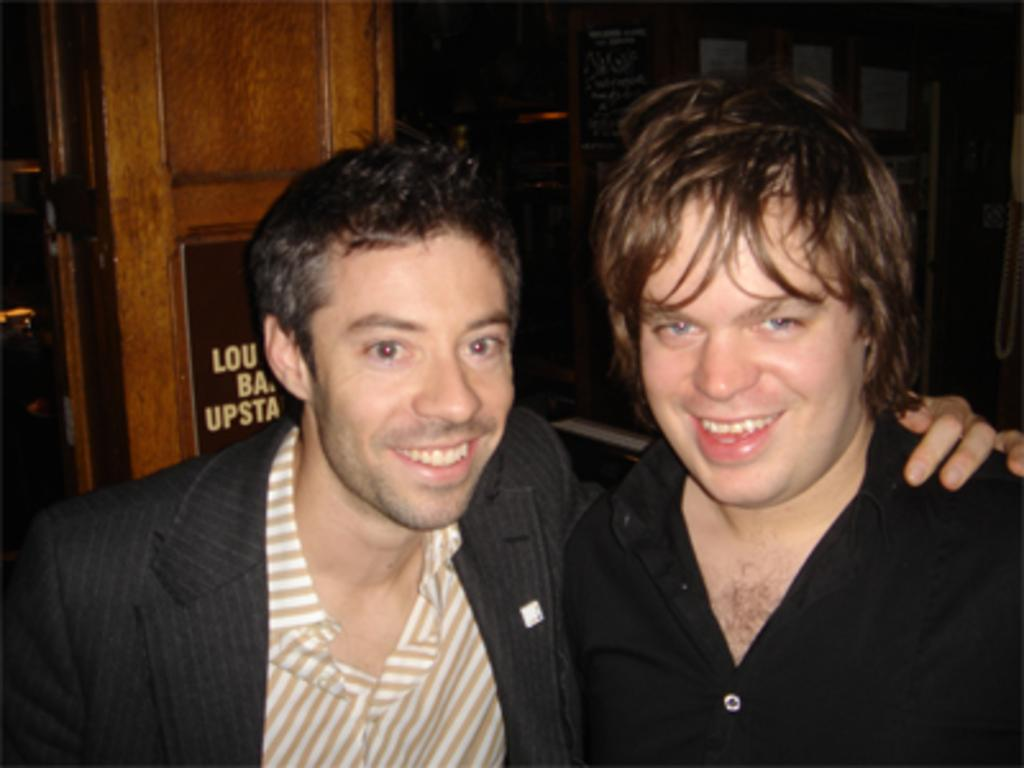How many people are in the image? There are two persons in the image. What are the people wearing? One person is wearing a black shirt, and the other person is wearing a suit. What can be seen in the background of the image? There is a door visible in the background. What is attached to the wall in the image? There are posters attached to the wall. What type of rock can be seen in the field in the image? There is no field or rock present in the image. Can you describe the sound of the thunder in the image? There is no thunder present in the image. 